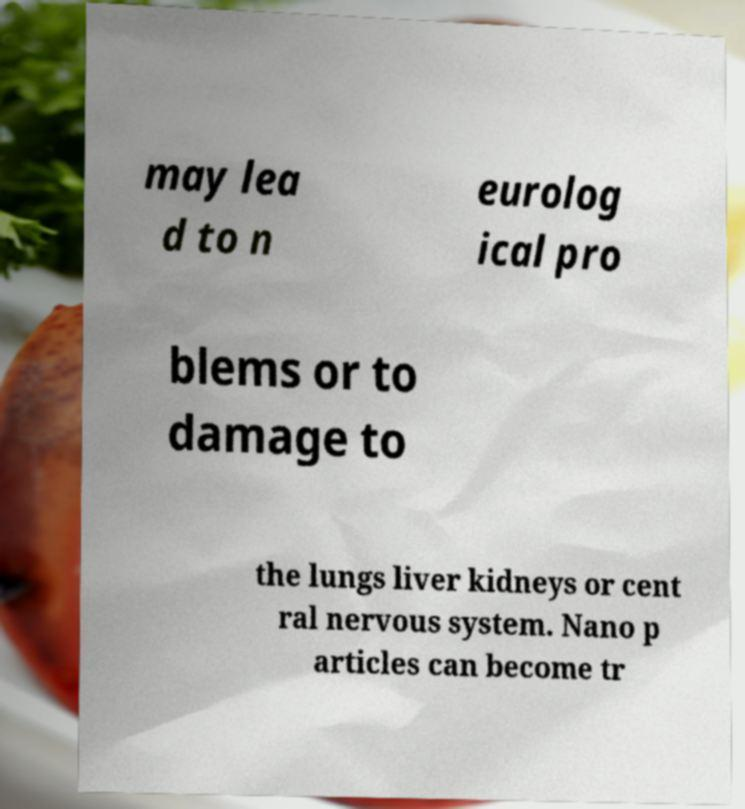What messages or text are displayed in this image? I need them in a readable, typed format. may lea d to n eurolog ical pro blems or to damage to the lungs liver kidneys or cent ral nervous system. Nano p articles can become tr 